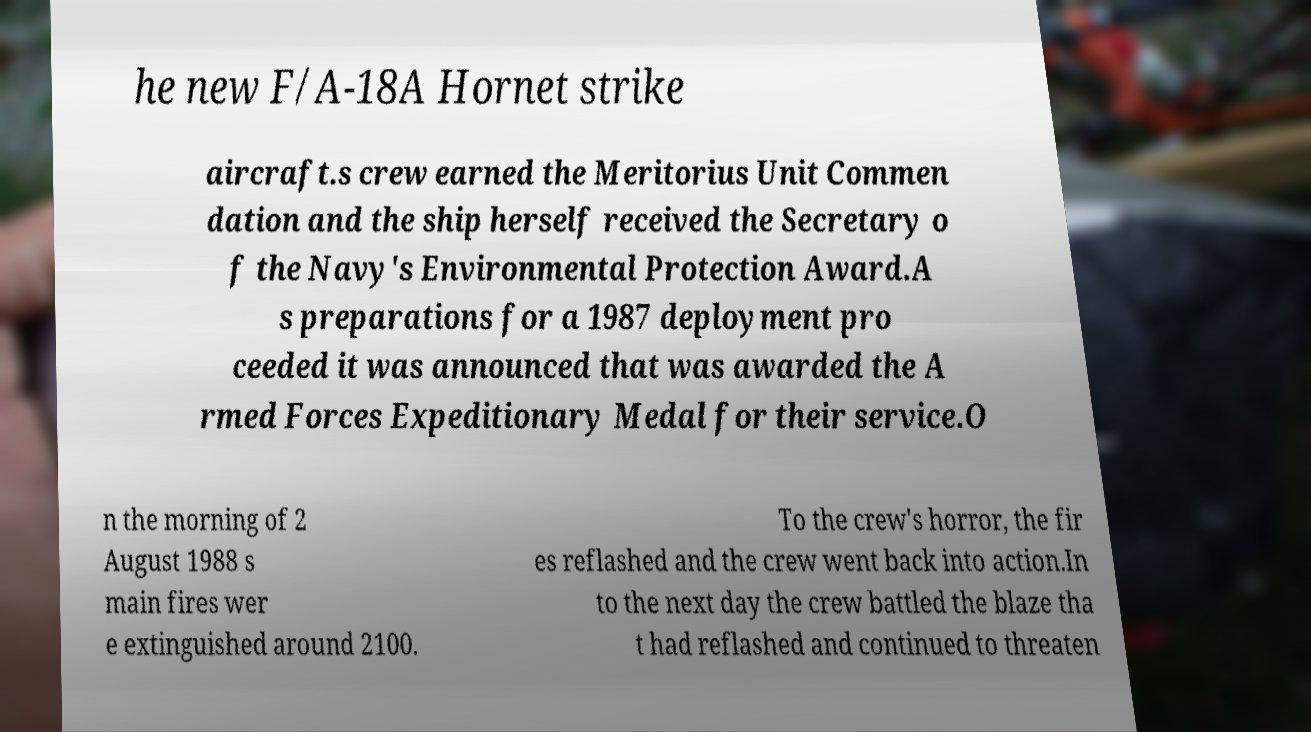I need the written content from this picture converted into text. Can you do that? he new F/A-18A Hornet strike aircraft.s crew earned the Meritorius Unit Commen dation and the ship herself received the Secretary o f the Navy's Environmental Protection Award.A s preparations for a 1987 deployment pro ceeded it was announced that was awarded the A rmed Forces Expeditionary Medal for their service.O n the morning of 2 August 1988 s main fires wer e extinguished around 2100. To the crew's horror, the fir es reflashed and the crew went back into action.In to the next day the crew battled the blaze tha t had reflashed and continued to threaten 